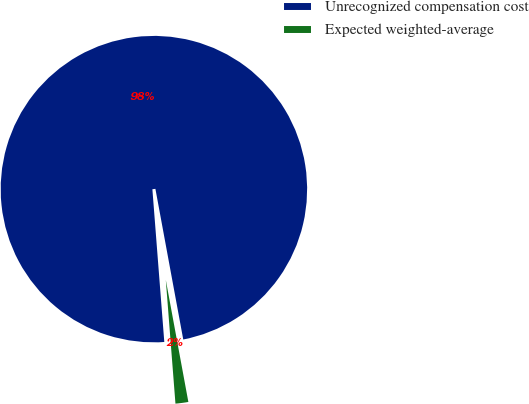<chart> <loc_0><loc_0><loc_500><loc_500><pie_chart><fcel>Unrecognized compensation cost<fcel>Expected weighted-average<nl><fcel>98.33%<fcel>1.67%<nl></chart> 